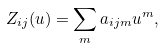Convert formula to latex. <formula><loc_0><loc_0><loc_500><loc_500>Z _ { i j } ( u ) = \sum _ { m } a _ { i j m } u ^ { m } ,</formula> 